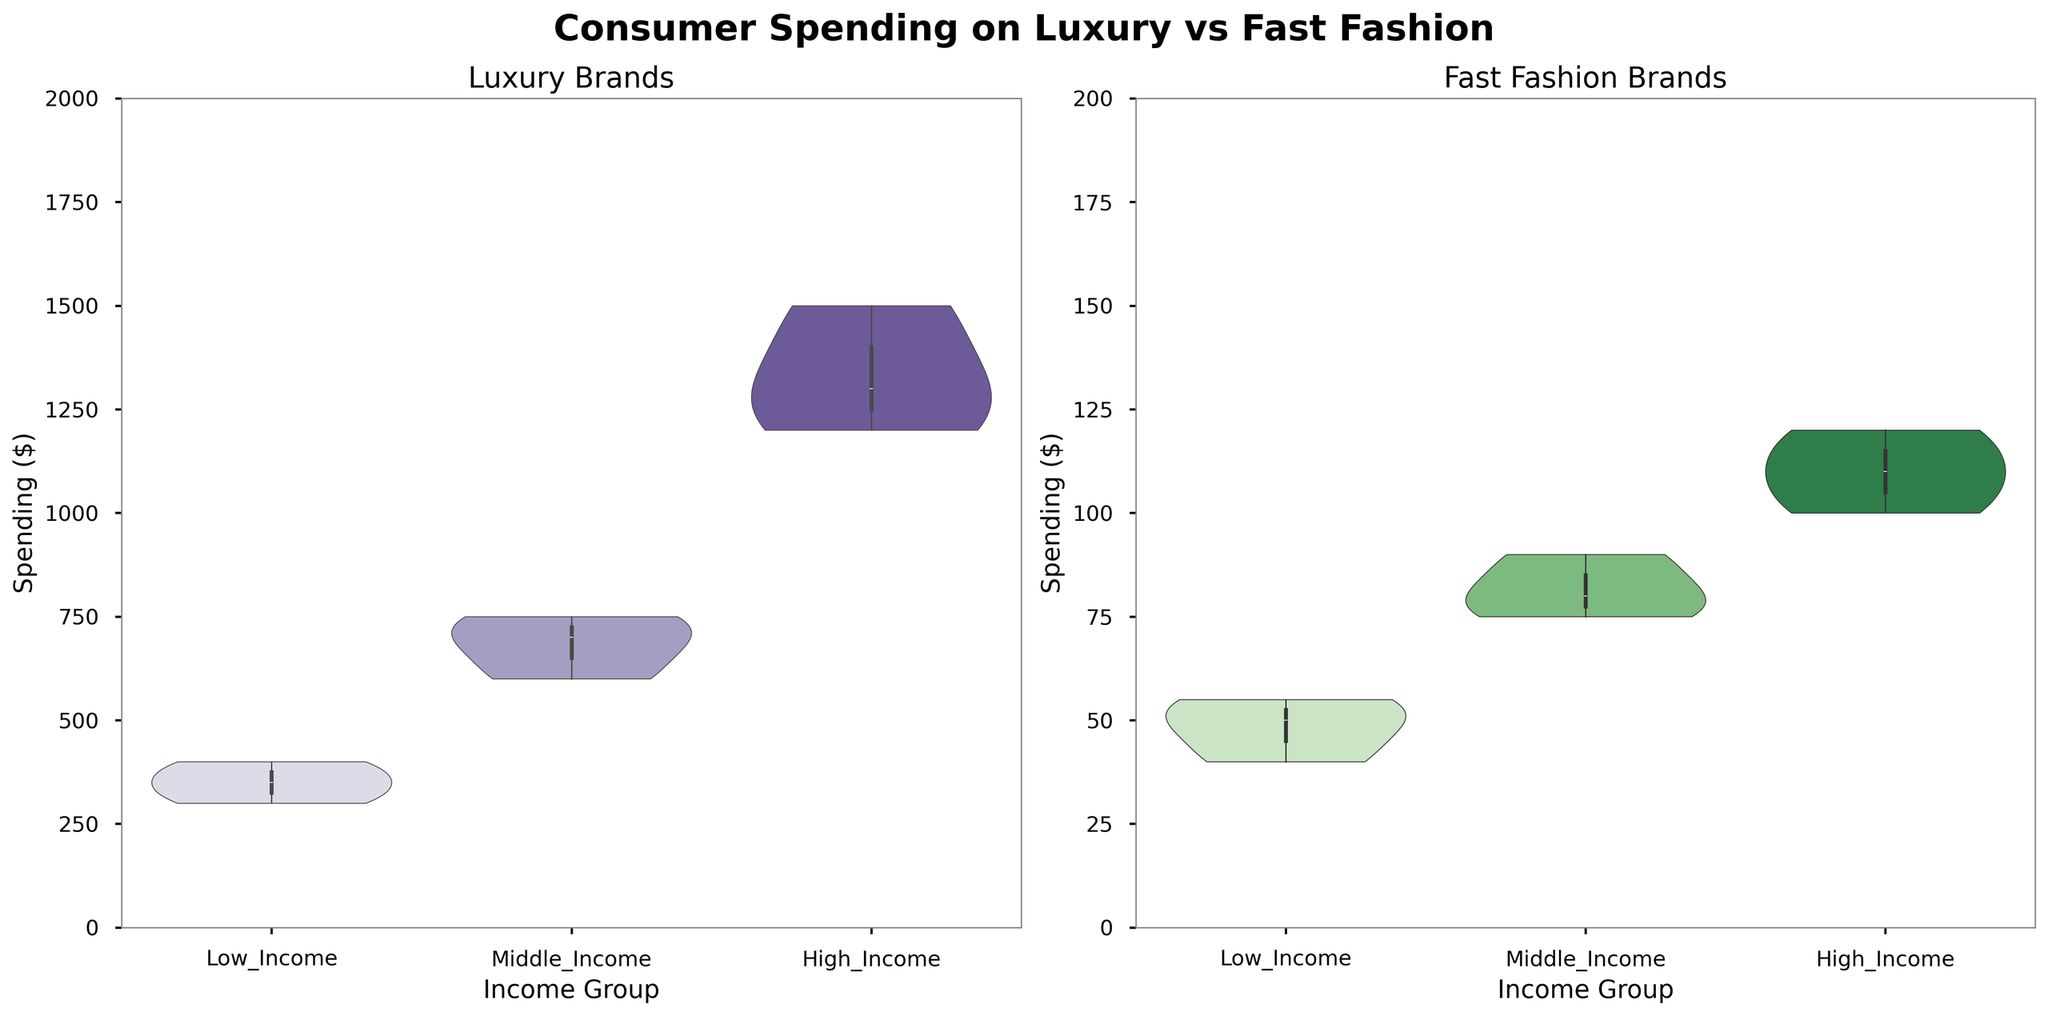What is the title of the subplot on the left? The title of the subplot on the left is located at the top of that subplot. It reads "Luxury Brands" as indicated in the figure.
Answer: Luxury Brands What is the maximum spending amount for fast fashion items? The maximum spending for fast fashion items can be observed on the y-axis of the subplot on the right. It reaches up to $200 as marked on the y-axis.
Answer: $200 Which income group spends the most on luxury brands? By examining the median lines inside the violin plots on the left subplot for each income group, it's clear that the High_Income group has the highest expenditure, as the median line is higher compared to other income groups.
Answer: High_Income What is the range of spending on fast fashion items for the Middle_Income group? The range is determined by the highest and lowest points within the kernel density estimate for the Middle_Income group in the right subplot. Observing this, the range for Middle_Income spending is from approximately $50 to $100.
Answer: $50-$100 How does the spending of Low_Income and High_Income groups on fast fashion items compare? In the right subplot, by comparing the positions of the median lines, it is clear that the High_Income group spends slightly more on fast fashion items than the Low_Income group, as indicated by higher median and broader distributions.
Answer: High_Income spends more Is there a significant difference between the highest spending on luxury brands and fast fashion items for the High_Income group? The highest spending on luxury brands for the High_Income group can be observed at around $1500, whereas for fast fashion items it is around $120. The difference between the two maximum values is significant.
Answer: Yes Which type of brand shows more variability in spending within each income group? Inspecting both subplots, prominence of the "spreading" of the data points in the violin plots shows more variability in the range for Luxury Brands (left subplot), especially in the High_Income group.
Answer: Luxury Brands For which income group is the median spending on fast fashion items the highest? The median spending on fast fashion items can be seen by the central lines within the violin plots in the right subplot. The highest median spending is observed for the High_Income group.
Answer: High_Income What is the spending range for luxury brands in the Low_Income group? By looking at the left subplot, the spending for luxury brands in the Low_Income group ranges from $300 to $400, as observed from the top and bottom extents of the data points.
Answer: $300-$400 